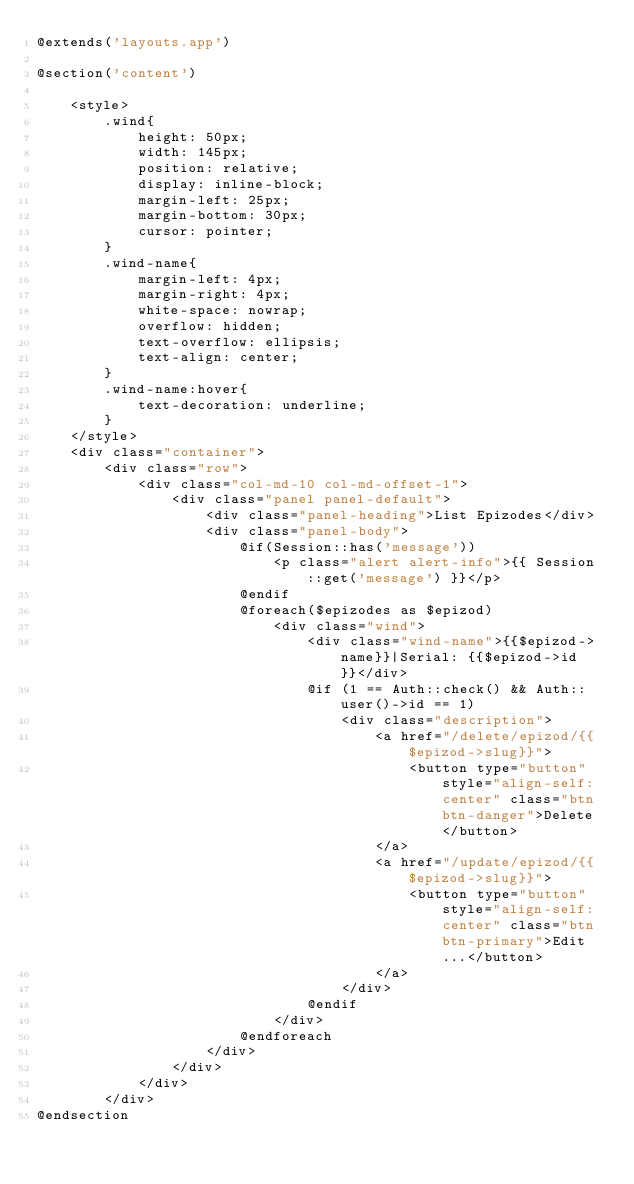Convert code to text. <code><loc_0><loc_0><loc_500><loc_500><_PHP_>@extends('layouts.app')

@section('content')

    <style>
        .wind{
            height: 50px;
            width: 145px;
            position: relative;
            display: inline-block;
            margin-left: 25px;
            margin-bottom: 30px;
            cursor: pointer;
        }
        .wind-name{
            margin-left: 4px;
            margin-right: 4px;
            white-space: nowrap;
            overflow: hidden;
            text-overflow: ellipsis;
            text-align: center;
        }
        .wind-name:hover{
            text-decoration: underline;
        }
    </style>
    <div class="container">
        <div class="row">
            <div class="col-md-10 col-md-offset-1">
                <div class="panel panel-default">
                    <div class="panel-heading">List Epizodes</div>
                    <div class="panel-body">
                        @if(Session::has('message'))
                            <p class="alert alert-info">{{ Session::get('message') }}</p>
                        @endif
                        @foreach($epizodes as $epizod)
                            <div class="wind">
                                <div class="wind-name">{{$epizod->name}}|Serial: {{$epizod->id}}</div>
                                @if (1 == Auth::check() && Auth::user()->id == 1)
                                    <div class="description">
                                        <a href="/delete/epizod/{{$epizod->slug}}">
                                            <button type="button" style="align-self: center" class="btn btn-danger">Delete</button>
                                        </a>
                                        <a href="/update/epizod/{{$epizod->slug}}">
                                            <button type="button" style="align-self: center" class="btn btn-primary">Edit...</button>
                                        </a>
                                    </div>
                                @endif
                            </div>
                        @endforeach
                    </div>
                </div>
            </div>
        </div>
@endsection

</code> 